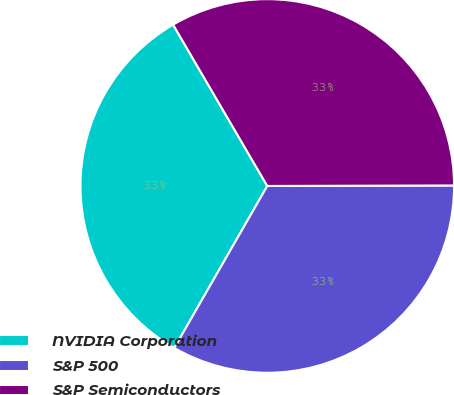<chart> <loc_0><loc_0><loc_500><loc_500><pie_chart><fcel>NVIDIA Corporation<fcel>S&P 500<fcel>S&P Semiconductors<nl><fcel>33.3%<fcel>33.33%<fcel>33.37%<nl></chart> 